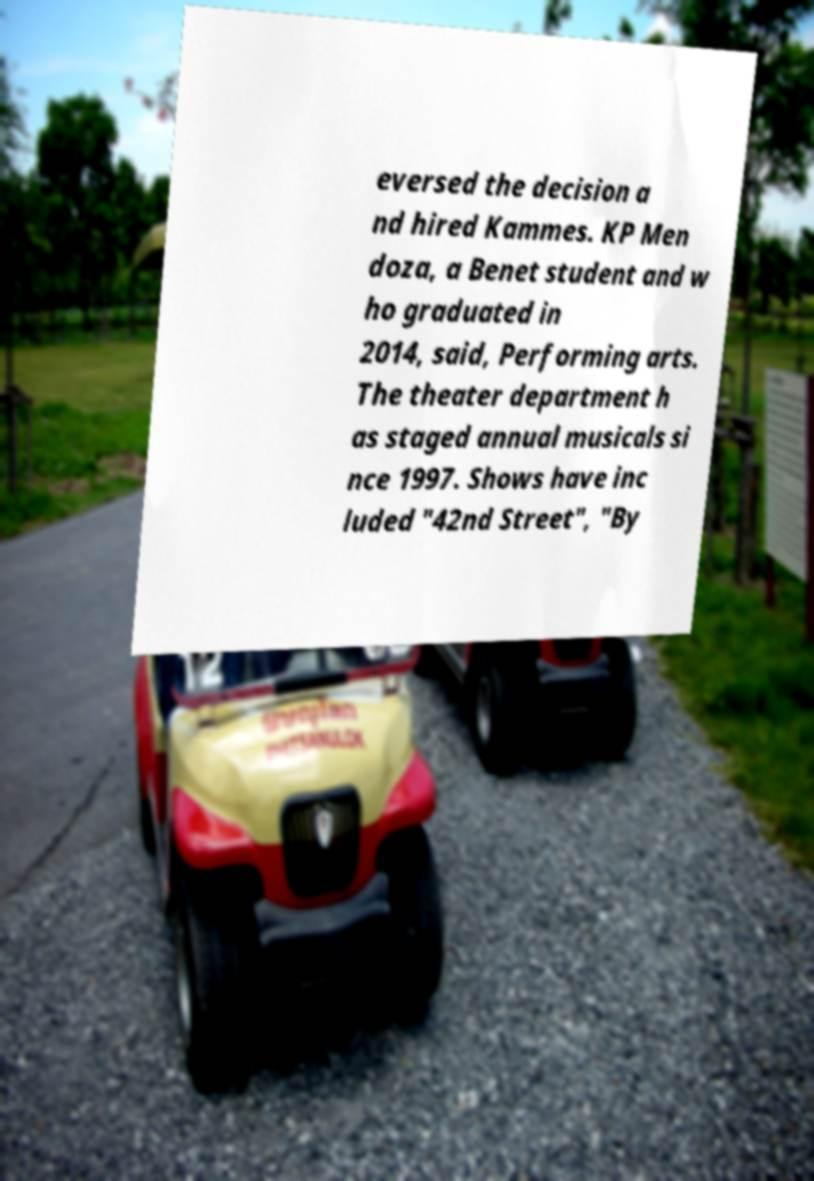I need the written content from this picture converted into text. Can you do that? eversed the decision a nd hired Kammes. KP Men doza, a Benet student and w ho graduated in 2014, said, Performing arts. The theater department h as staged annual musicals si nce 1997. Shows have inc luded "42nd Street", "By 